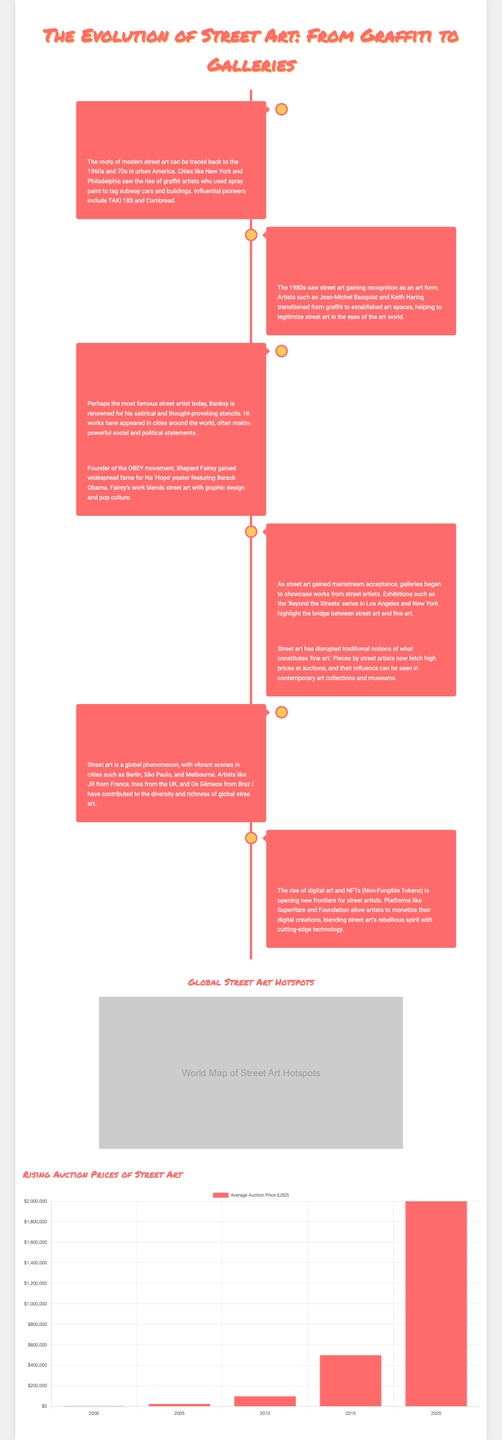What decade is noted for the origins of street art? The document states that the origins of street art can be traced back to the 1960s and 70s.
Answer: 1960s and 70s Who are two influential pioneers of graffiti mentioned? The document mentions TAKI 183 and Cornbread as influential pioneers of graffiti.
Answer: TAKI 183 and Cornbread Which artist is associated with the 'Hope' poster? Shepard Fairey is identified in the document as the artist who created the 'Hope' poster featuring Barack Obama.
Answer: Shepard Fairey What significant event occurred in street art during the 1980s? The 1980s saw street art gaining recognition as an art form, with artists transitioning from graffiti to established art spaces.
Answer: Recognition as an art form What does the rise of digital art and NFTs signify for street artists? The document explains that the rise of digital art and NFTs is opening new frontiers for street artists to monetize their digital creations.
Answer: New frontiers for monetization Which city is mentioned as having a vibrant street art scene, besides New York? The document lists Berlin, São Paulo, and Melbourne as cities with vibrant street art scenes.
Answer: Berlin, São Paulo, and Melbourne What year is indicated for an average auction price reaching $2,000,000? The chart in the document specifies the year 2020 for the average auction price reaching $2,000,000.
Answer: 2020 What term is used to describe the commercialization of street art? The term "Commercialization" is used in the document to describe the shift of street art into galleries.
Answer: Commercialization Which artist is highlighted for using satirical stencils? Banksy is identified in the document as the artist renowned for his satirical and thought-provoking stencils.
Answer: Banksy 